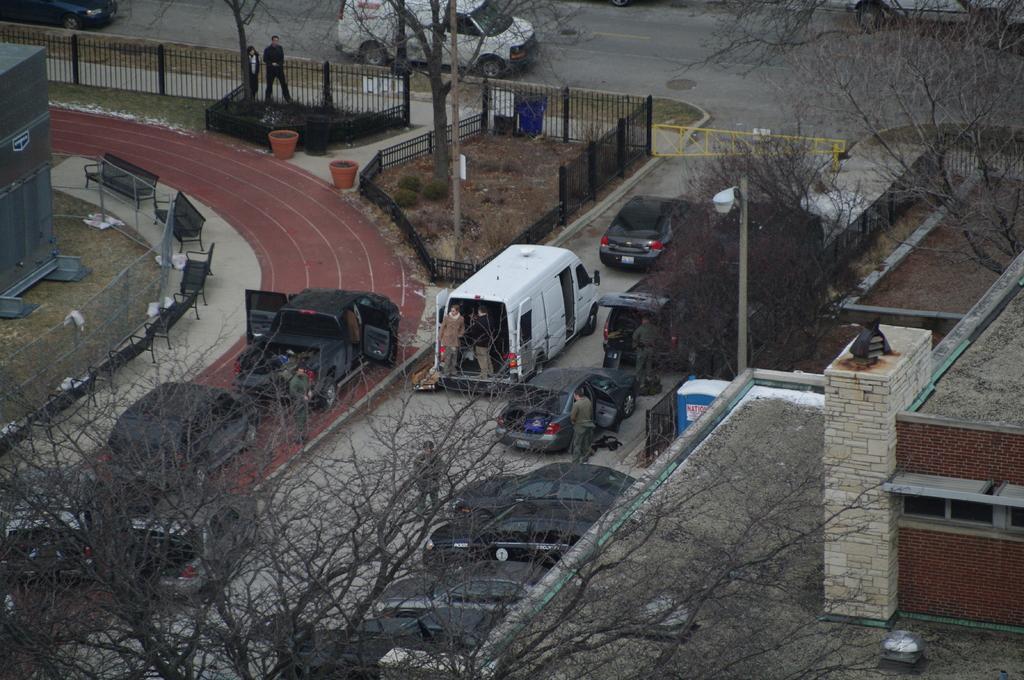Could you give a brief overview of what you see in this image? In this image I can see few vehicles on the road. To the right I can see the buildings. I can see few people, trees and the poles. To the left I can see the container and the benches. In the background I can see the the railing. 